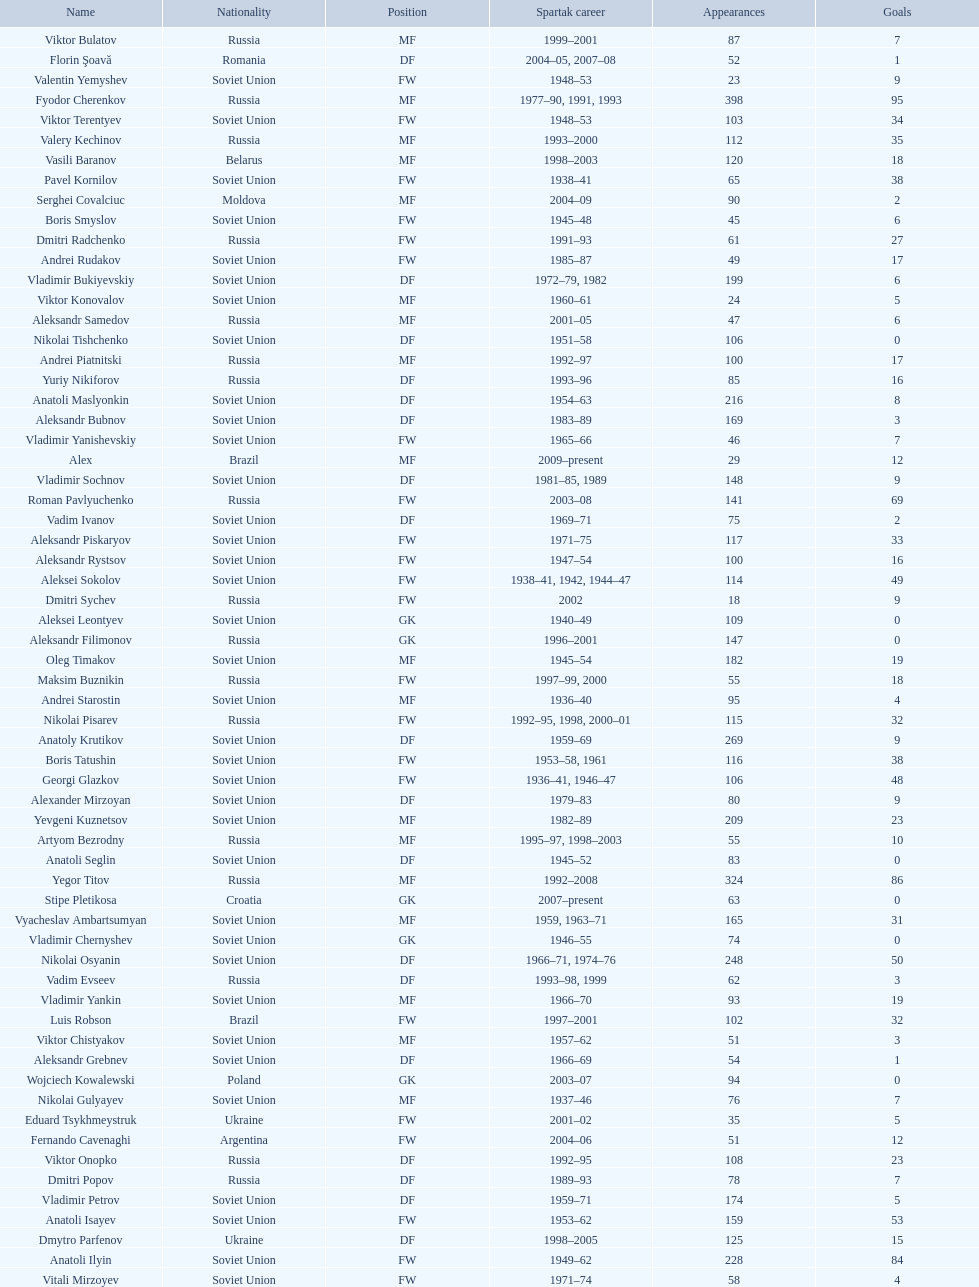How many players had at least 20 league goals scored? 56. 